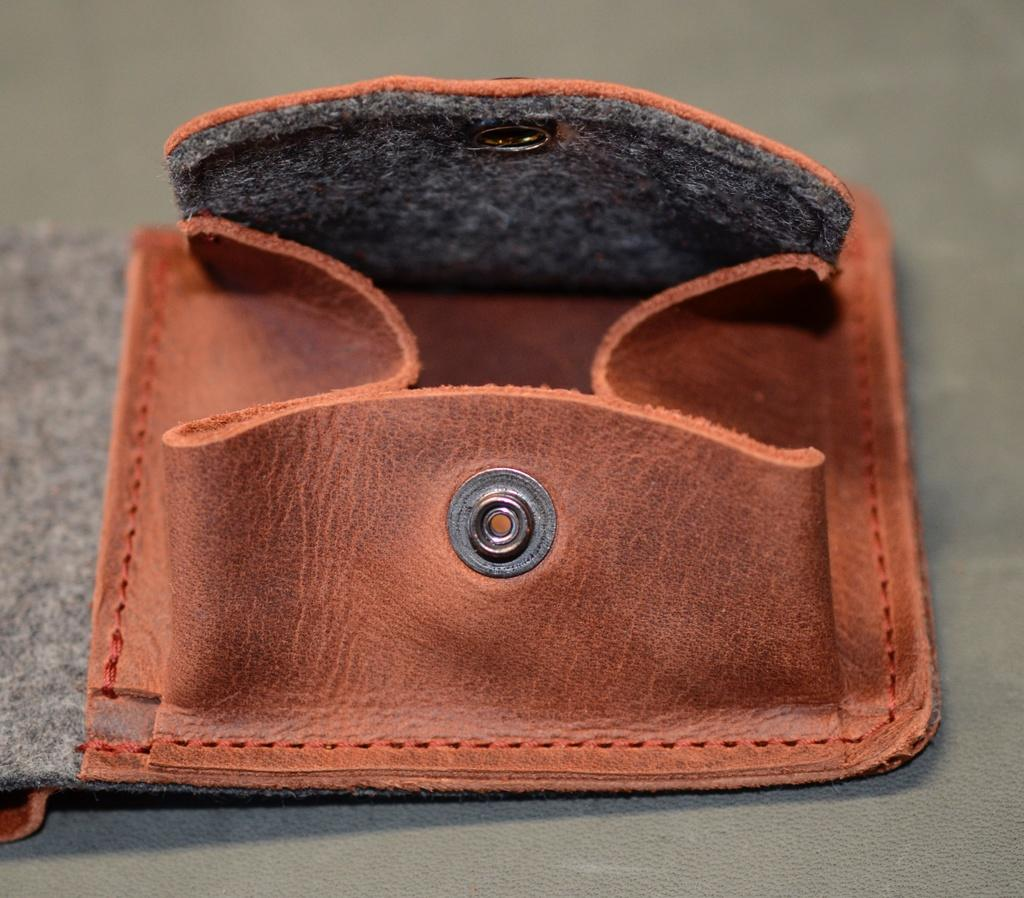What is located in the middle of the image? There is a purse in the middle of the image. Where is the house located in the image? There is no house present in the image; it only features a purse. What type of nest can be seen in the image? There is no nest present in the image; it only features a purse. 